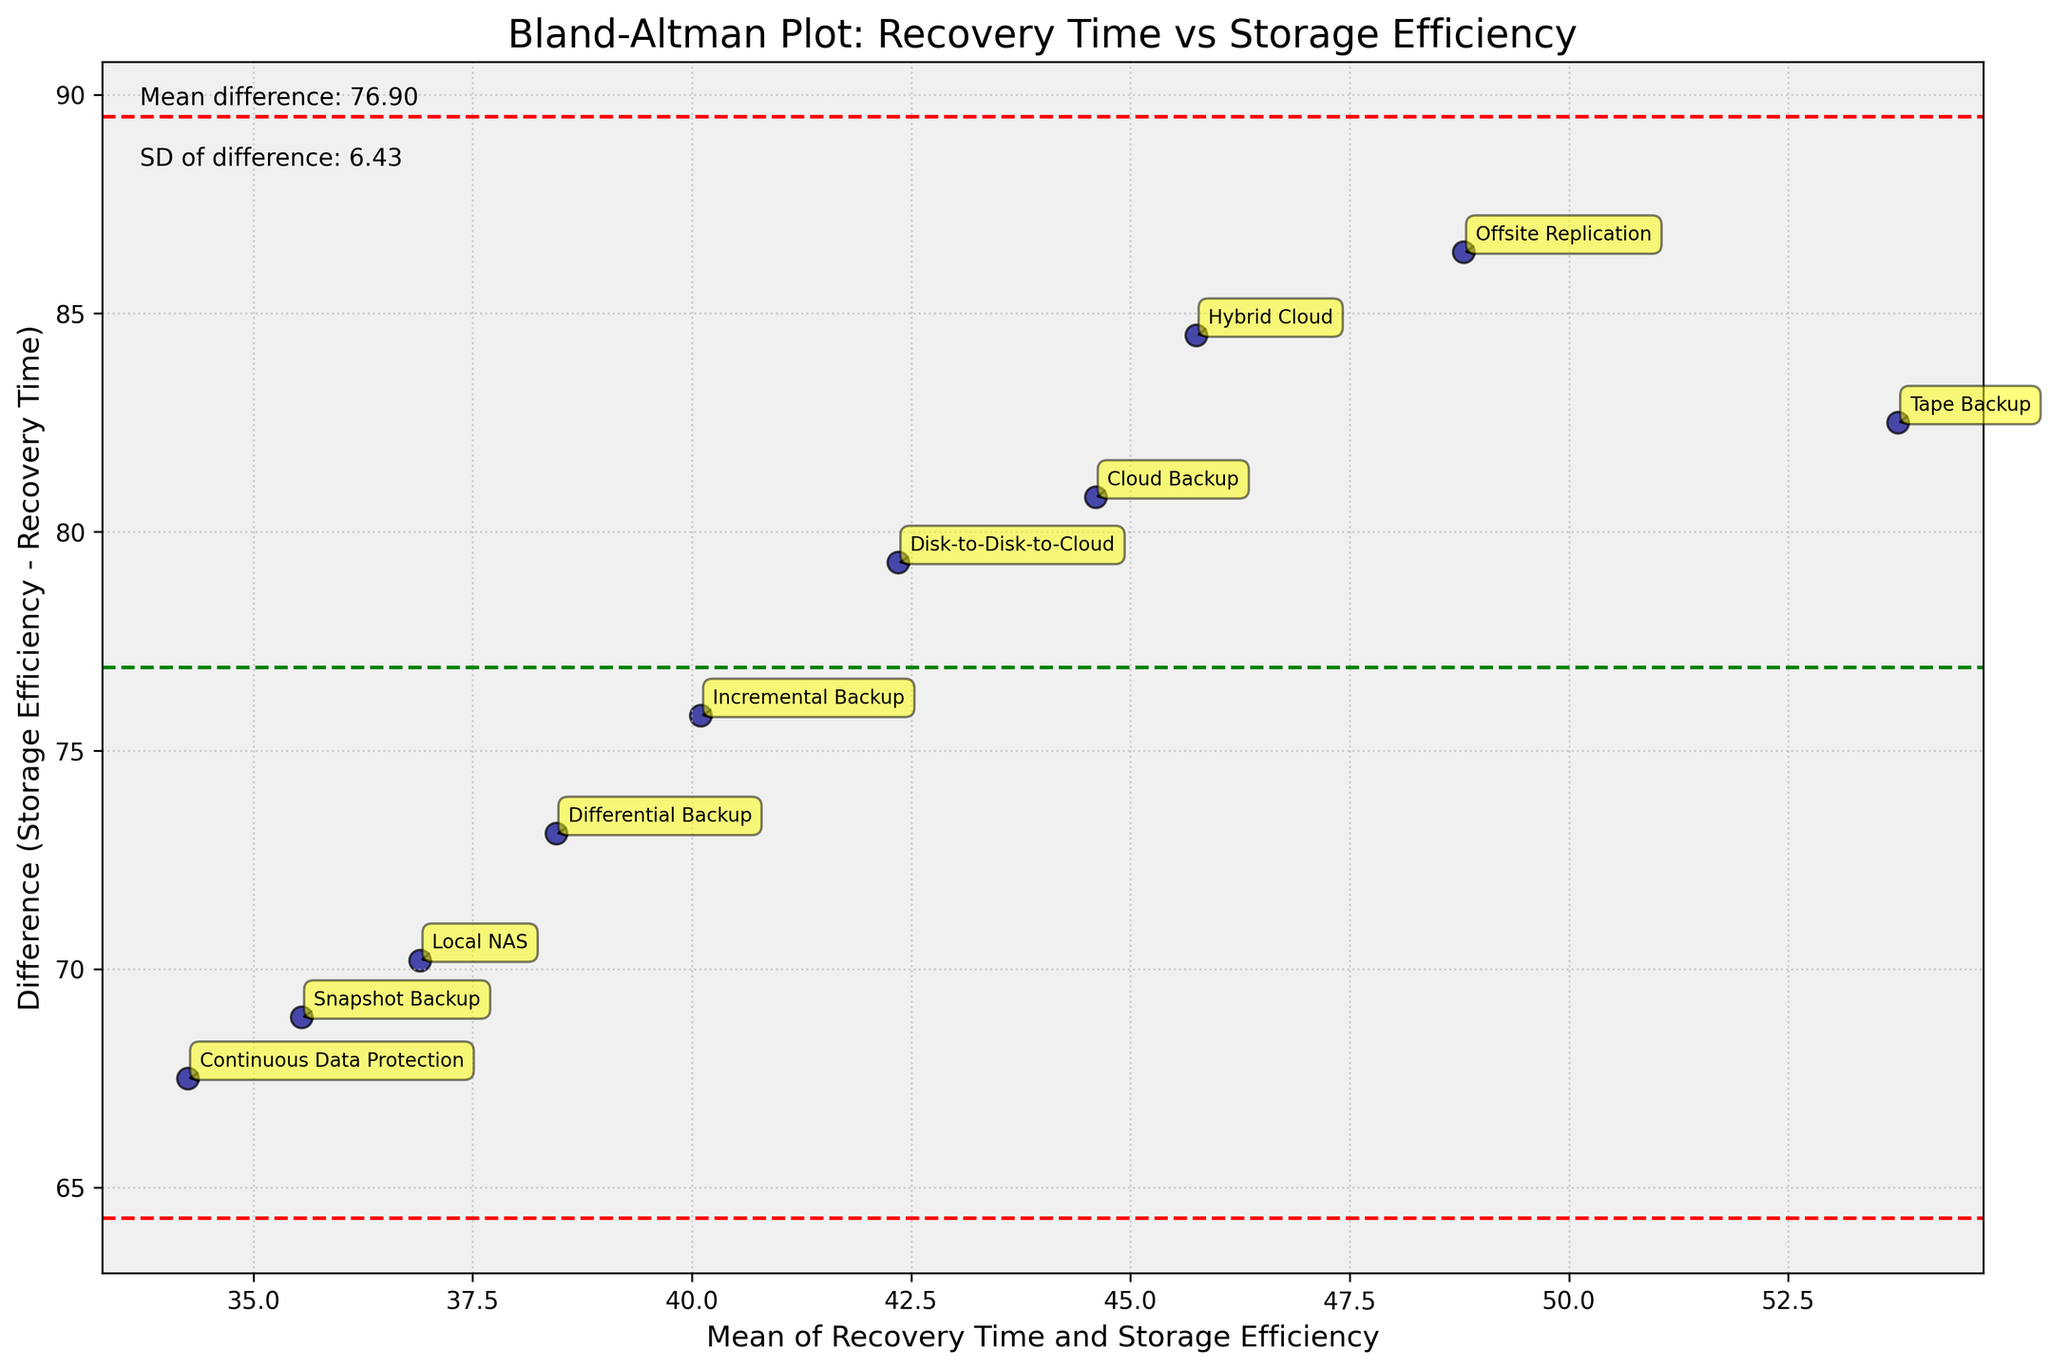What's the title of the plot? The title of a plot is usually located at the top-center of the figure.
Answer: Bland-Altman Plot: Recovery Time vs Storage Efficiency How many data points are there in the plot? You count the number of points (dots) scattered across the plot.
Answer: 10 What do the green and red dashed lines represent? The green dashed line represents the mean difference, and the red dashed lines represent the limits of agreement (mean difference ± 1.96 standard deviations).
Answer: Mean difference and limits of agreement Which data point has the highest difference value? You locate the point farthest from the mean difference line along the y-axis. Look for the text label of the method.
Answer: Tape Backup What's the mean difference between storage efficiency and recovery time? The mean difference is provided in the text annotation in the top left of the plot.
Answer: Approximately 66.74 Which backup strategy has the lowest recovery time? Look for the point on the far left side of the x-axis and check its corresponding label.
Answer: Continuous Data Protection Which methods lie outside the limits of agreement? Identify points that are outside the range of the red dashed lines.
Answer: Local NAS, Tape Backup, Offsite Replication What is the standard deviation of the difference? The standard deviation of the difference is provided in the text annotation in the top left of the plot.
Answer: Approximately 78.65 